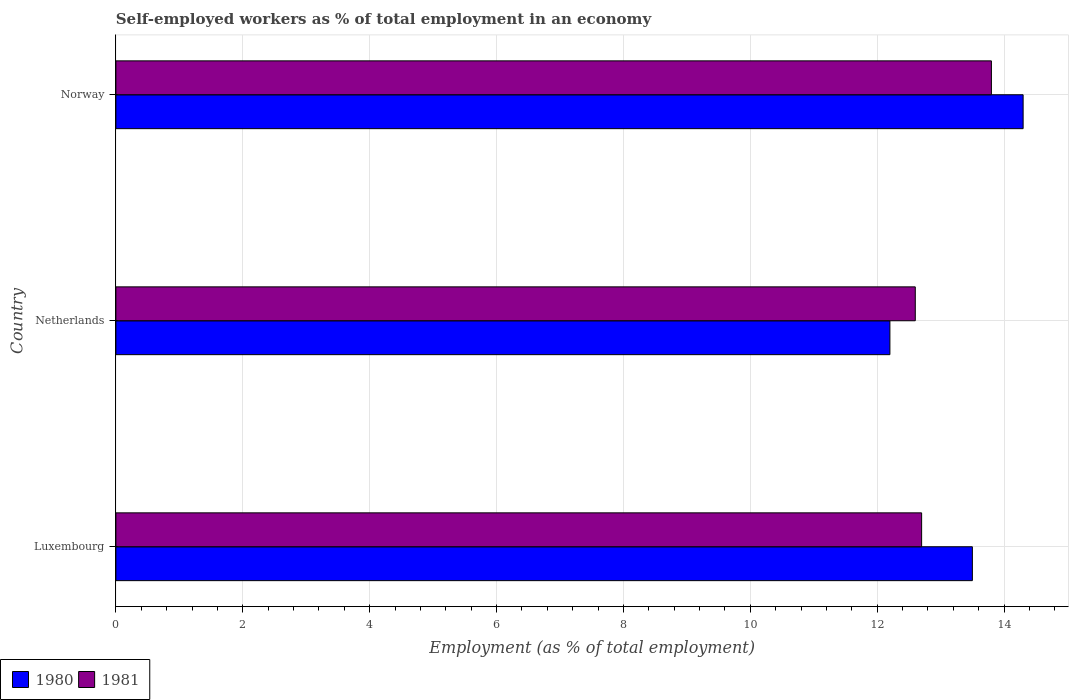How many different coloured bars are there?
Offer a very short reply. 2. Are the number of bars on each tick of the Y-axis equal?
Keep it short and to the point. Yes. How many bars are there on the 2nd tick from the bottom?
Keep it short and to the point. 2. What is the label of the 2nd group of bars from the top?
Provide a short and direct response. Netherlands. What is the percentage of self-employed workers in 1981 in Luxembourg?
Give a very brief answer. 12.7. Across all countries, what is the maximum percentage of self-employed workers in 1980?
Provide a succinct answer. 14.3. Across all countries, what is the minimum percentage of self-employed workers in 1981?
Keep it short and to the point. 12.6. In which country was the percentage of self-employed workers in 1980 minimum?
Provide a succinct answer. Netherlands. What is the total percentage of self-employed workers in 1981 in the graph?
Keep it short and to the point. 39.1. What is the difference between the percentage of self-employed workers in 1981 in Luxembourg and that in Norway?
Your answer should be very brief. -1.1. What is the average percentage of self-employed workers in 1980 per country?
Offer a very short reply. 13.33. What is the difference between the percentage of self-employed workers in 1981 and percentage of self-employed workers in 1980 in Norway?
Keep it short and to the point. -0.5. In how many countries, is the percentage of self-employed workers in 1980 greater than 12.4 %?
Offer a very short reply. 2. What is the ratio of the percentage of self-employed workers in 1981 in Luxembourg to that in Netherlands?
Your response must be concise. 1.01. Is the percentage of self-employed workers in 1981 in Netherlands less than that in Norway?
Ensure brevity in your answer.  Yes. Is the difference between the percentage of self-employed workers in 1981 in Netherlands and Norway greater than the difference between the percentage of self-employed workers in 1980 in Netherlands and Norway?
Your answer should be very brief. Yes. What is the difference between the highest and the second highest percentage of self-employed workers in 1980?
Provide a short and direct response. 0.8. What is the difference between the highest and the lowest percentage of self-employed workers in 1981?
Your answer should be very brief. 1.2. In how many countries, is the percentage of self-employed workers in 1981 greater than the average percentage of self-employed workers in 1981 taken over all countries?
Provide a short and direct response. 1. Is the sum of the percentage of self-employed workers in 1981 in Luxembourg and Norway greater than the maximum percentage of self-employed workers in 1980 across all countries?
Provide a short and direct response. Yes. What does the 2nd bar from the top in Netherlands represents?
Your answer should be very brief. 1980. How many bars are there?
Offer a very short reply. 6. How many countries are there in the graph?
Your response must be concise. 3. What is the difference between two consecutive major ticks on the X-axis?
Give a very brief answer. 2. Does the graph contain any zero values?
Give a very brief answer. No. Where does the legend appear in the graph?
Your answer should be compact. Bottom left. How many legend labels are there?
Your answer should be compact. 2. How are the legend labels stacked?
Give a very brief answer. Horizontal. What is the title of the graph?
Ensure brevity in your answer.  Self-employed workers as % of total employment in an economy. What is the label or title of the X-axis?
Offer a very short reply. Employment (as % of total employment). What is the label or title of the Y-axis?
Offer a very short reply. Country. What is the Employment (as % of total employment) of 1981 in Luxembourg?
Provide a succinct answer. 12.7. What is the Employment (as % of total employment) of 1980 in Netherlands?
Your answer should be very brief. 12.2. What is the Employment (as % of total employment) of 1981 in Netherlands?
Offer a terse response. 12.6. What is the Employment (as % of total employment) of 1980 in Norway?
Your answer should be compact. 14.3. What is the Employment (as % of total employment) in 1981 in Norway?
Give a very brief answer. 13.8. Across all countries, what is the maximum Employment (as % of total employment) of 1980?
Ensure brevity in your answer.  14.3. Across all countries, what is the maximum Employment (as % of total employment) in 1981?
Provide a short and direct response. 13.8. Across all countries, what is the minimum Employment (as % of total employment) in 1980?
Provide a short and direct response. 12.2. Across all countries, what is the minimum Employment (as % of total employment) in 1981?
Offer a terse response. 12.6. What is the total Employment (as % of total employment) of 1981 in the graph?
Your answer should be compact. 39.1. What is the difference between the Employment (as % of total employment) of 1980 in Luxembourg and that in Norway?
Offer a very short reply. -0.8. What is the difference between the Employment (as % of total employment) of 1981 in Luxembourg and that in Norway?
Keep it short and to the point. -1.1. What is the difference between the Employment (as % of total employment) in 1980 in Luxembourg and the Employment (as % of total employment) in 1981 in Netherlands?
Give a very brief answer. 0.9. What is the difference between the Employment (as % of total employment) of 1980 in Luxembourg and the Employment (as % of total employment) of 1981 in Norway?
Make the answer very short. -0.3. What is the average Employment (as % of total employment) in 1980 per country?
Keep it short and to the point. 13.33. What is the average Employment (as % of total employment) in 1981 per country?
Provide a short and direct response. 13.03. What is the difference between the Employment (as % of total employment) in 1980 and Employment (as % of total employment) in 1981 in Luxembourg?
Your response must be concise. 0.8. What is the ratio of the Employment (as % of total employment) in 1980 in Luxembourg to that in Netherlands?
Offer a terse response. 1.11. What is the ratio of the Employment (as % of total employment) of 1981 in Luxembourg to that in Netherlands?
Make the answer very short. 1.01. What is the ratio of the Employment (as % of total employment) of 1980 in Luxembourg to that in Norway?
Your answer should be very brief. 0.94. What is the ratio of the Employment (as % of total employment) of 1981 in Luxembourg to that in Norway?
Provide a short and direct response. 0.92. What is the ratio of the Employment (as % of total employment) in 1980 in Netherlands to that in Norway?
Offer a very short reply. 0.85. What is the difference between the highest and the second highest Employment (as % of total employment) in 1980?
Keep it short and to the point. 0.8. What is the difference between the highest and the lowest Employment (as % of total employment) in 1980?
Provide a succinct answer. 2.1. What is the difference between the highest and the lowest Employment (as % of total employment) in 1981?
Ensure brevity in your answer.  1.2. 